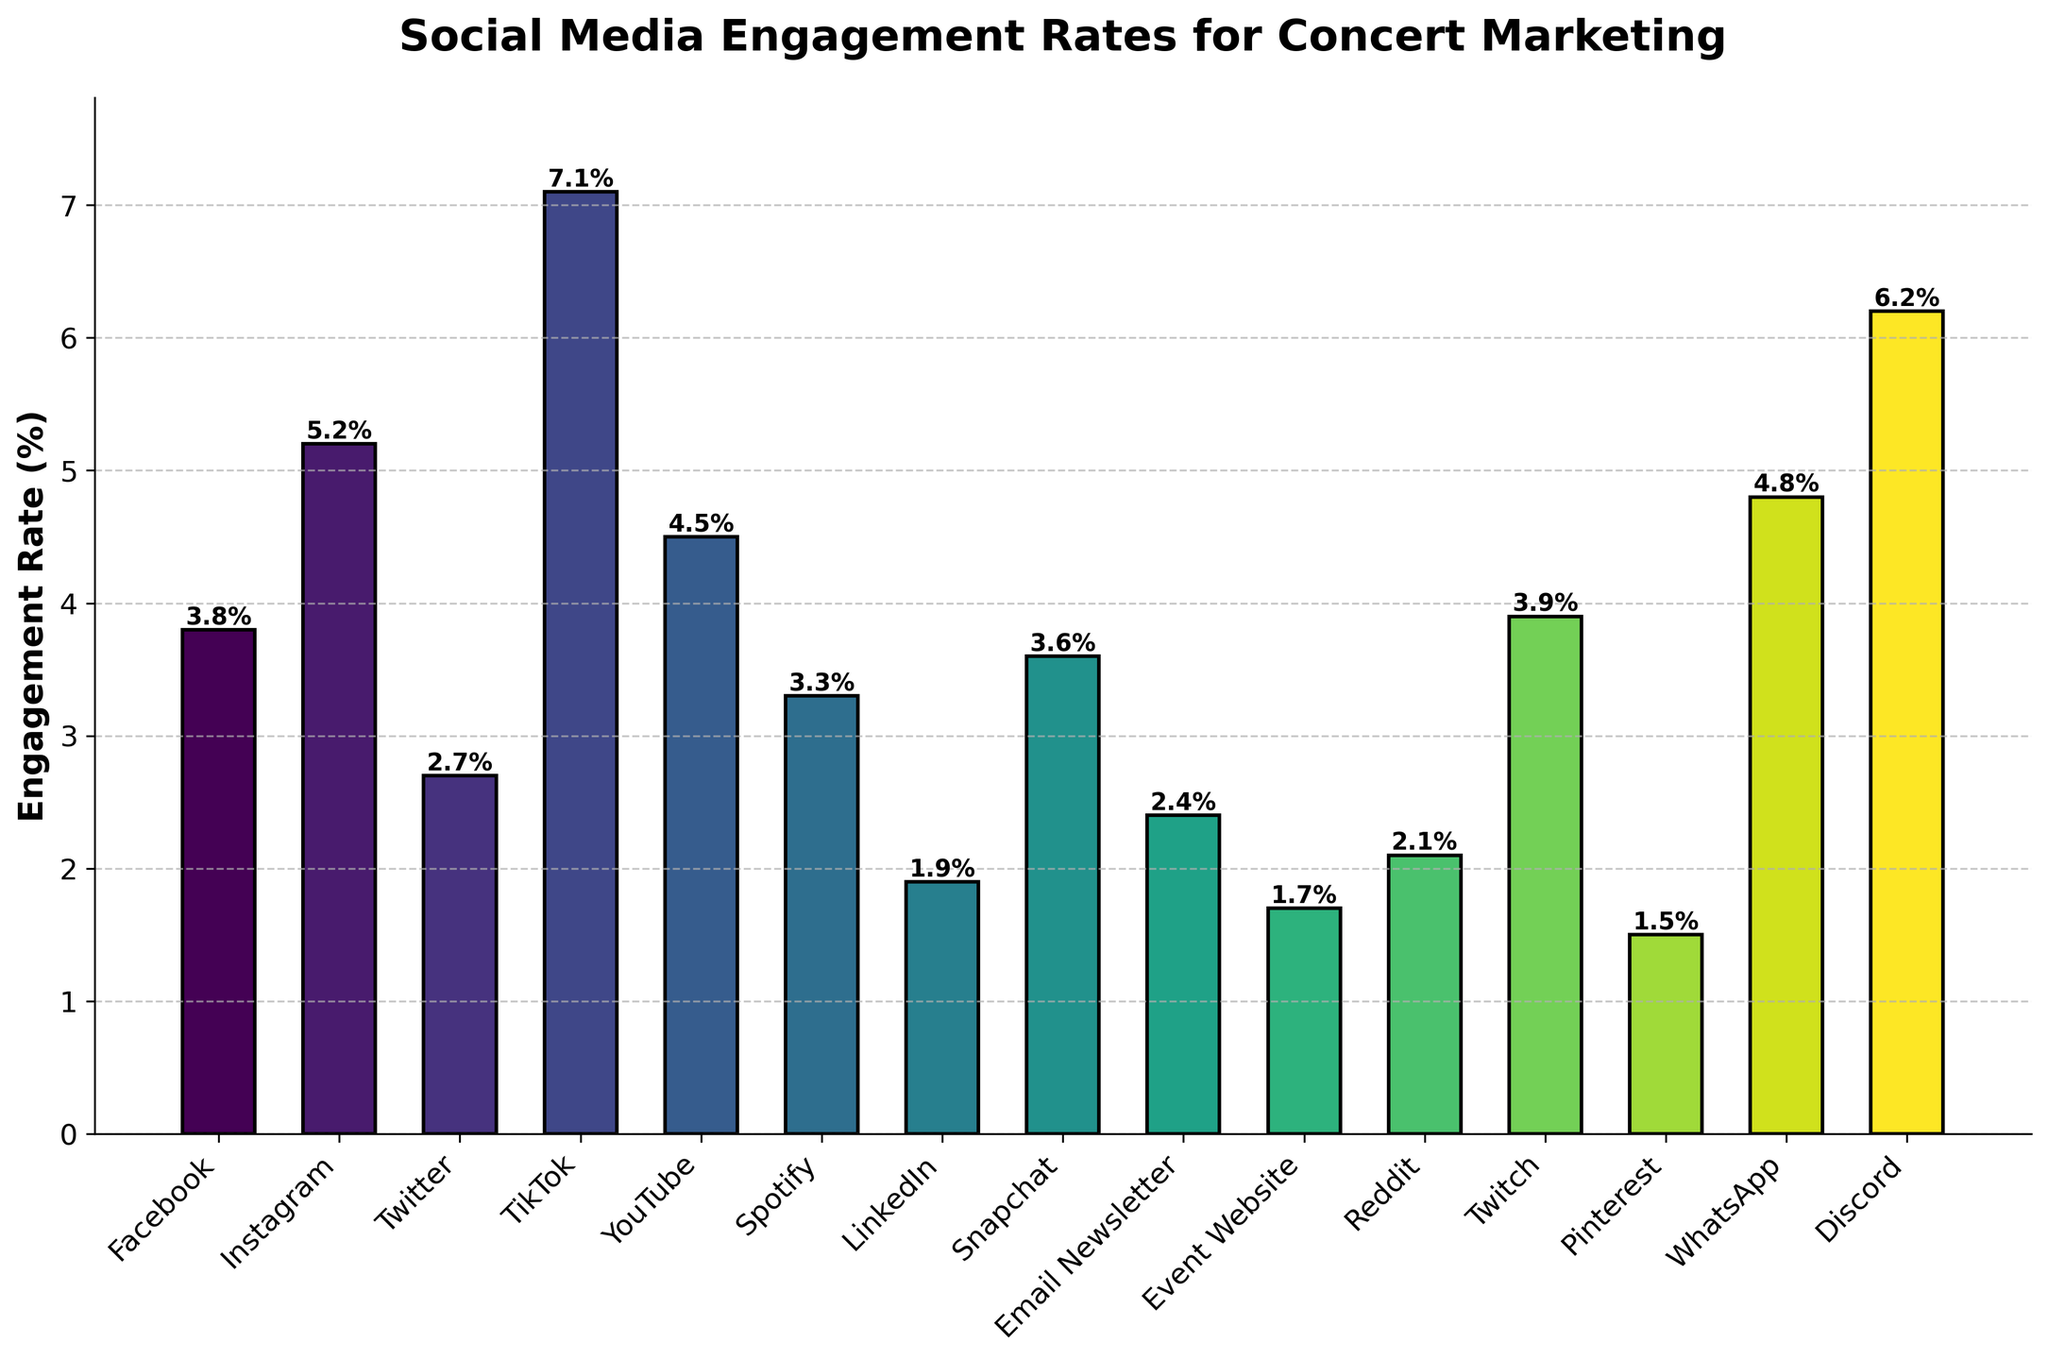Which promotional channel has the highest engagement rate? To answer, look for the tallest bar in the bar chart, which represents the highest engagement rate. The tallest bar is for the channel TikTok.
Answer: TikTok Which promotional channel has the lowest engagement rate? To identify the channel with the lowest engagement rate, locate the shortest bar in the bar chart. The shortest bar corresponds to Pinterest.
Answer: Pinterest How much higher is TikTok's engagement rate compared to Twitter's? Find the engagement rates for TikTok and Twitter from the bar heights. TikTok has 7.1% and Twitter has 2.7%. Calculate the difference: 7.1 - 2.7 = 4.4.
Answer: 4.4% Which channels have an engagement rate between 3% and 5%? Identify all bars whose height falls between 3% and 5%. These channels are Facebook (3.8%), YouTube (4.5%), Snapchat (3.6%), and WhatsApp (4.8%).
Answer: Facebook, YouTube, Snapchat, WhatsApp What is the average engagement rate of Instagram, Facebook, and Twitter? Find the engagement rates for Instagram (5.2%), Facebook (3.8%), and Twitter (2.7%). Sum them up and divide by 3: (5.2 + 3.8 + 2.7)/3 = 11.7/3 = 3.9.
Answer: 3.9% Is the engagement rate of WhatsApp higher than the engagement rate of Snapchat? Compare the heights of the bars for WhatsApp and Snapchat. WhatsApp has an engagement rate of 4.8%, and Snapchat has 3.6%. Since 4.8% > 3.6%, the WhatsApp engagement rate is higher.
Answer: Yes Which channel has a lower engagement rate, LinkedIn or Reddit? Compare the engagement rates of LinkedIn and Reddit by looking at their bar heights. LinkedIn has 1.9%, and Reddit has 2.1%. Since 1.9% < 2.1%, LinkedIn has a lower engagement rate.
Answer: LinkedIn What is the combined engagement rate of the top 3 highest engagement rate channels? Identify the top 3 highest bars, which are TikTok (7.1%), Discord (6.2%), and Instagram (5.2%). Sum them up: 7.1 + 6.2 + 5.2 = 18.5.
Answer: 18.5% Compare the engagement rates of Facebook and Twitter. How many percentage points higher is Facebook's rate? Find the engagement rates for Facebook (3.8%) and Twitter (2.7%). Subtract the lower rate from the higher rate: 3.8 - 2.7 = 1.1.
Answer: 1.1% What is the median engagement rate of all channels? List the engagement rates in numerical order: 1.5, 1.7, 1.9, 2.1, 2.4, 2.7, 3.3, 3.6, 3.8, 3.9, 4.5, 4.8, 5.2, 6.2, 7.1. Find the middle value, which is the 8th value in this ordered list. The median is 3.6%.
Answer: 3.6% 